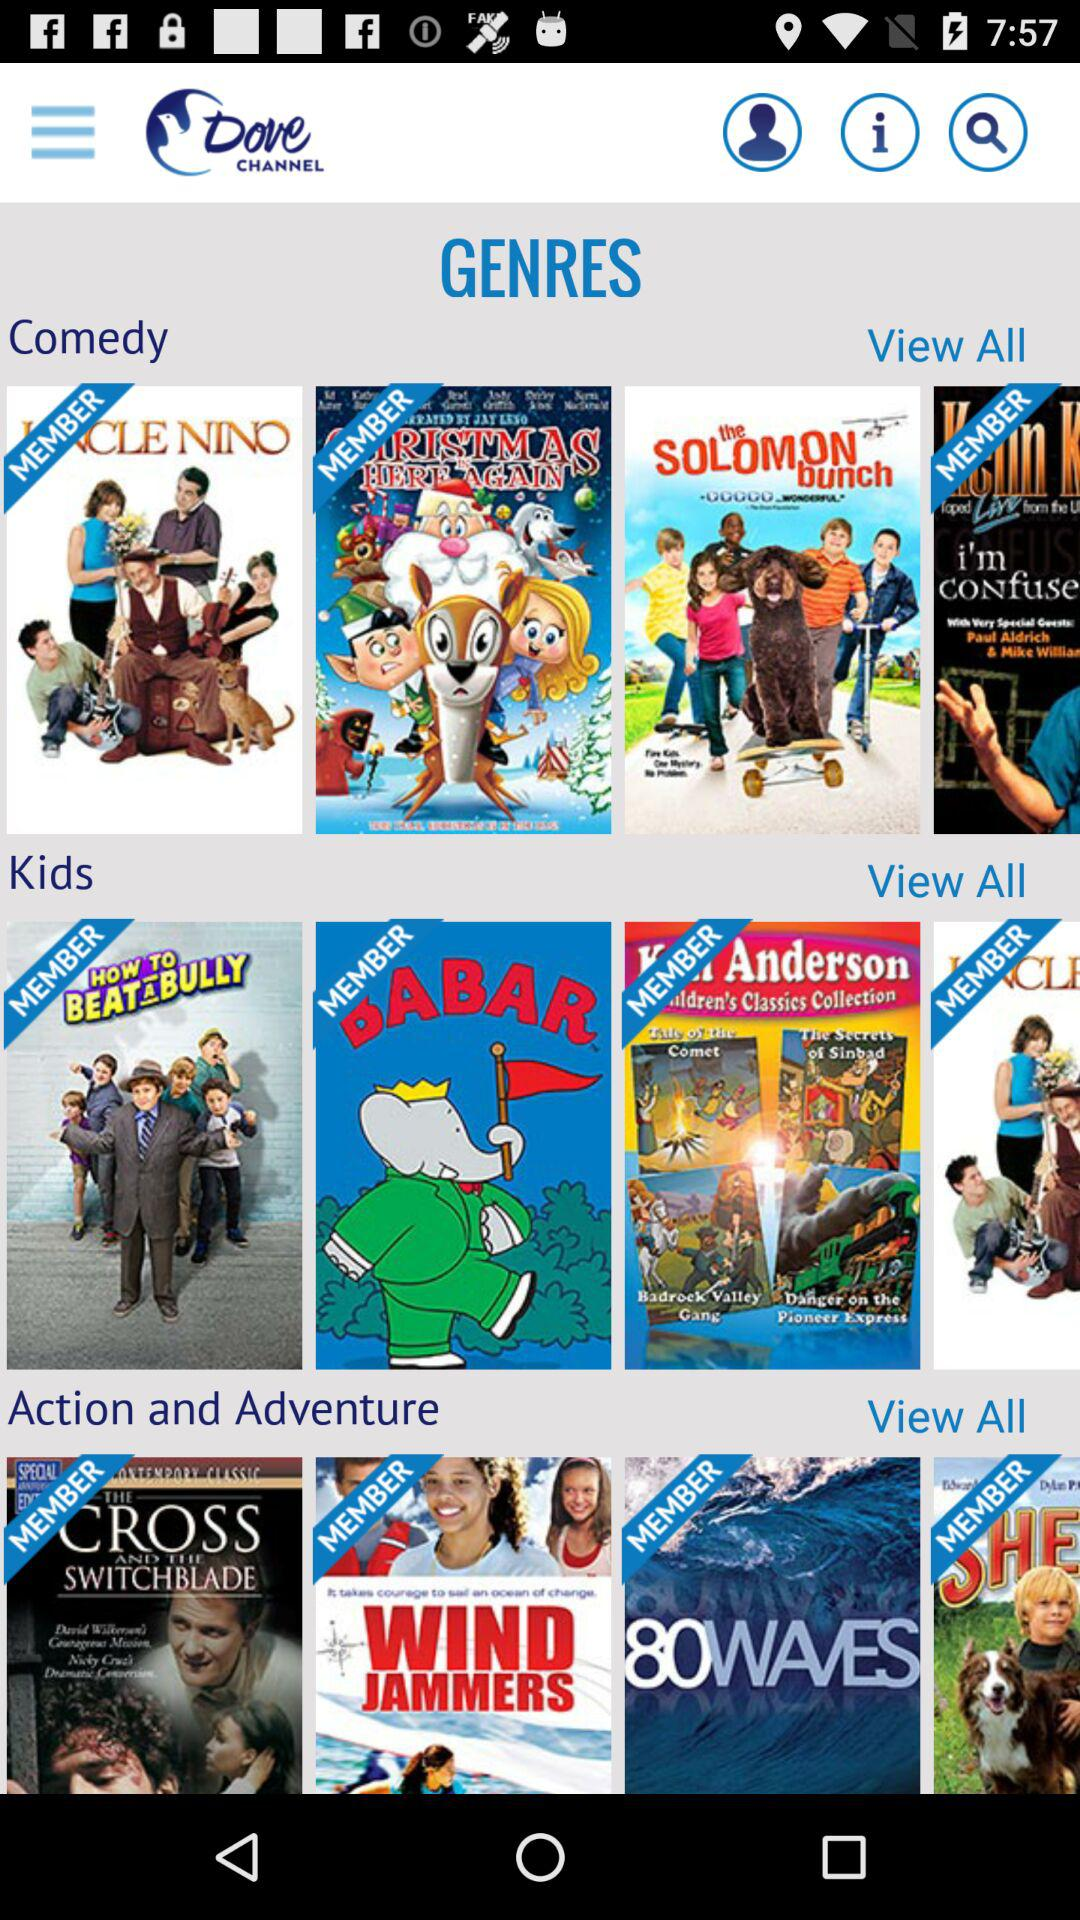What are the different categories of genres shown? The different categories of genres are "Comedy", "Kids" and "Action and Adventure". 